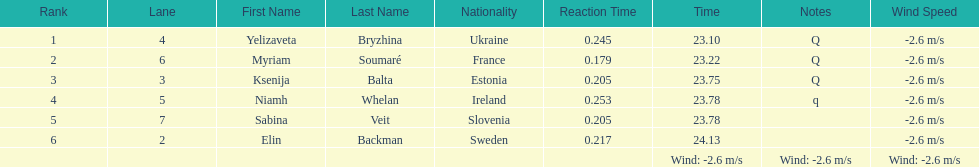The first person to finish in heat 1? Yelizaveta Bryzhina. 